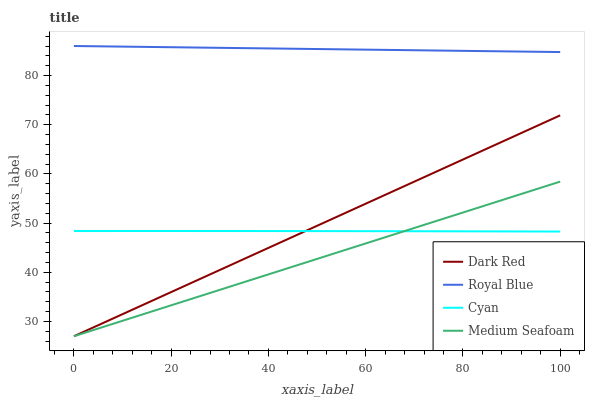Does Cyan have the minimum area under the curve?
Answer yes or no. No. Does Cyan have the maximum area under the curve?
Answer yes or no. No. Is Cyan the smoothest?
Answer yes or no. No. Is Medium Seafoam the roughest?
Answer yes or no. No. Does Cyan have the lowest value?
Answer yes or no. No. Does Medium Seafoam have the highest value?
Answer yes or no. No. Is Cyan less than Royal Blue?
Answer yes or no. Yes. Is Royal Blue greater than Medium Seafoam?
Answer yes or no. Yes. Does Cyan intersect Royal Blue?
Answer yes or no. No. 